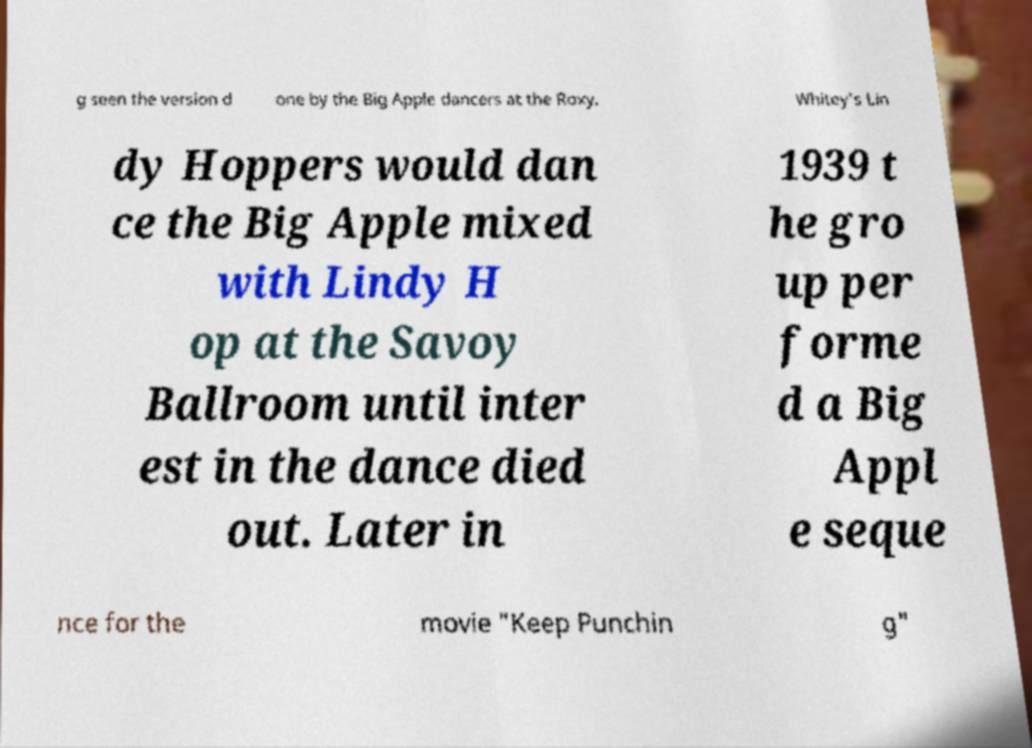Please read and relay the text visible in this image. What does it say? g seen the version d one by the Big Apple dancers at the Roxy. Whitey's Lin dy Hoppers would dan ce the Big Apple mixed with Lindy H op at the Savoy Ballroom until inter est in the dance died out. Later in 1939 t he gro up per forme d a Big Appl e seque nce for the movie "Keep Punchin g" 